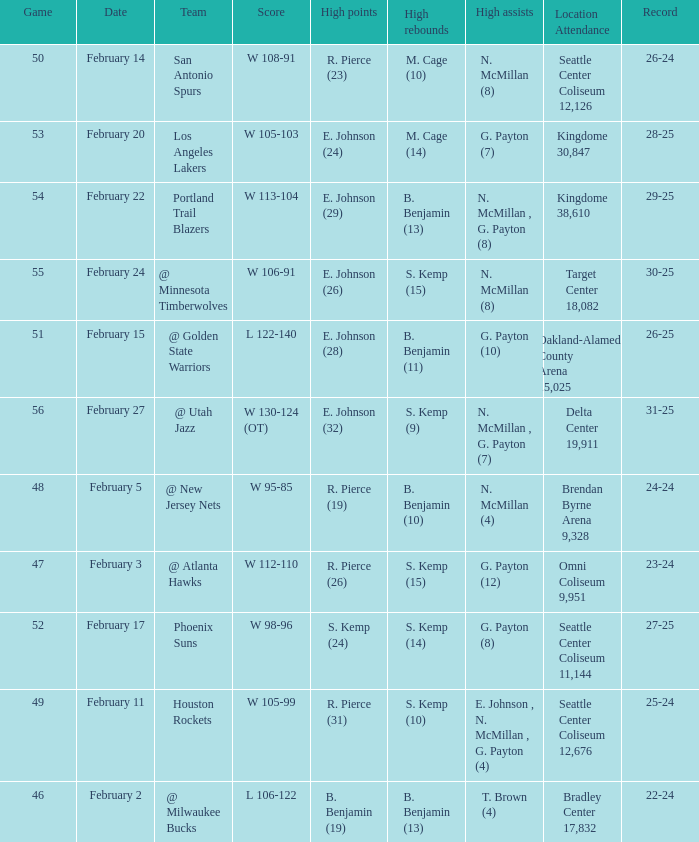Which game had a score of w 95-85? 48.0. 